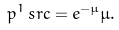Convert formula to latex. <formula><loc_0><loc_0><loc_500><loc_500>p ^ { 1 } _ { \ } s r c = e ^ { - \mu } \mu .</formula> 